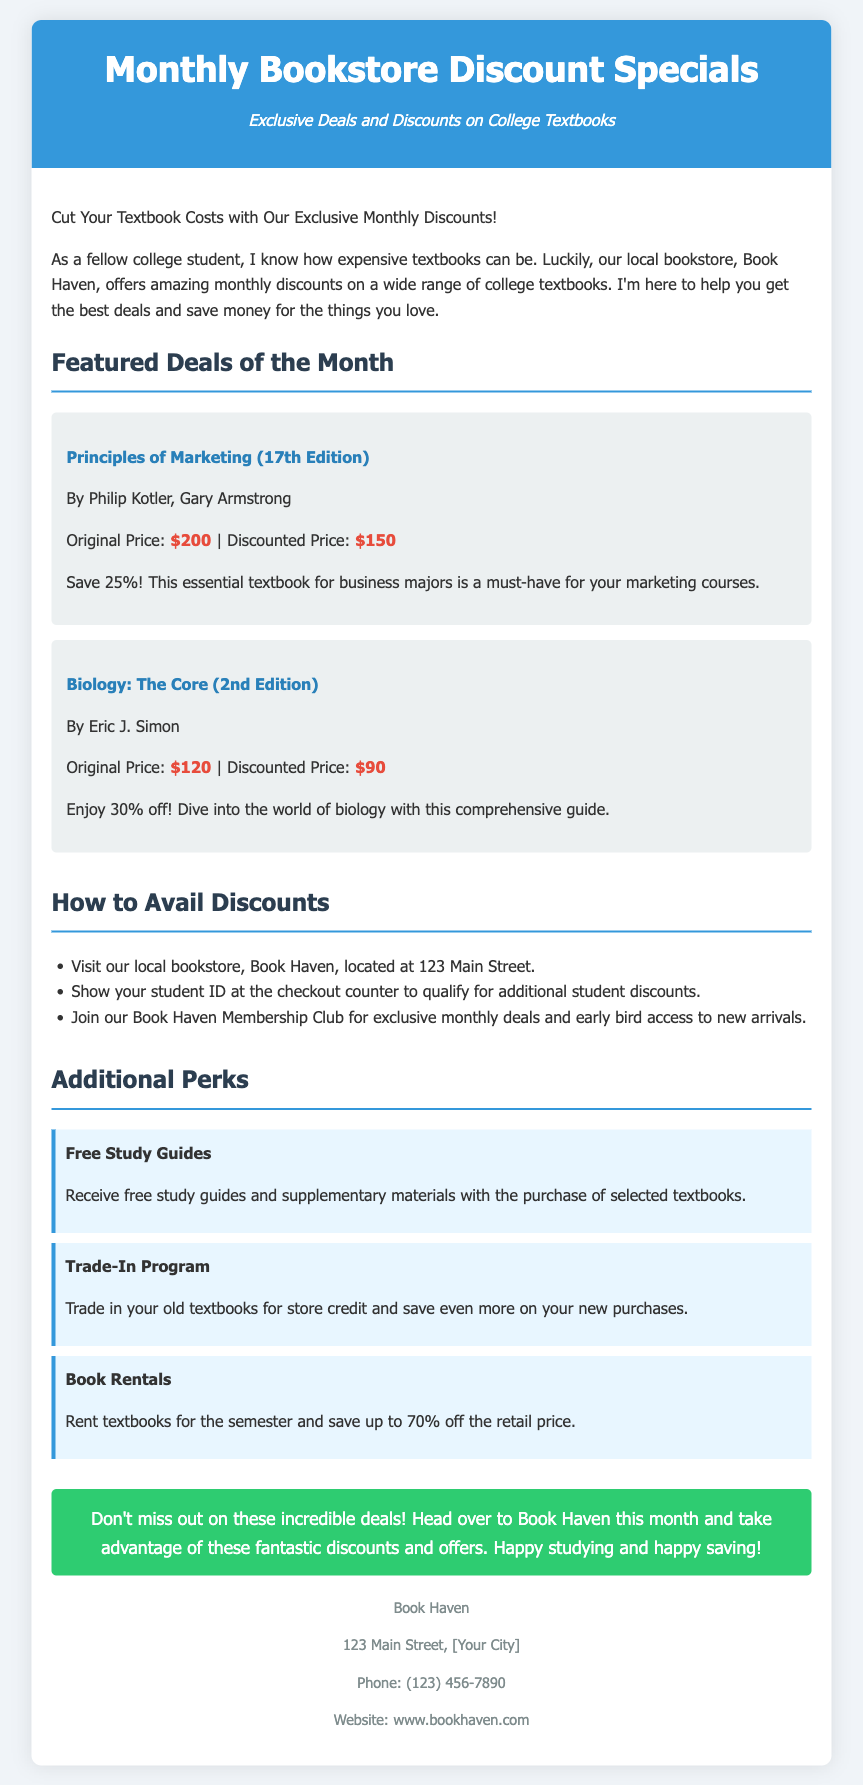What is the name of the bookstore? The document mentions the name of the bookstore as Book Haven.
Answer: Book Haven What is the original price of "Biology: The Core"? The original price stated in the document for "Biology: The Core" is $120.
Answer: $120 How much can students save on "Principles of Marketing"? The discount offered for "Principles of Marketing" is 25%, meaning students save $50 off the original price.
Answer: $50 What address is provided for Book Haven? The document lists the address as 123 Main Street.
Answer: 123 Main Street What percentage discount is offered for Biology: The Core? The document states that Biology: The Core is discounted by 30%.
Answer: 30% How do you qualify for additional student discounts? According to the document, presenting a student ID at checkout qualifies students for additional discounts.
Answer: Student ID What is one additional perk mentioned in the document? The document lists free study guides as one of the additional perks provided to customers.
Answer: Free study guides What benefit does the Trade-In Program offer? The Trade-In Program allows students to receive store credit for turning in their old textbooks.
Answer: Store credit What is the phone number for Book Haven? The document provides the contact number as (123) 456-7890.
Answer: (123) 456-7890 What should students do to join the membership club? Students need to join the Book Haven Membership Club to access exclusive deals, as stated in the document.
Answer: Join the Membership Club 